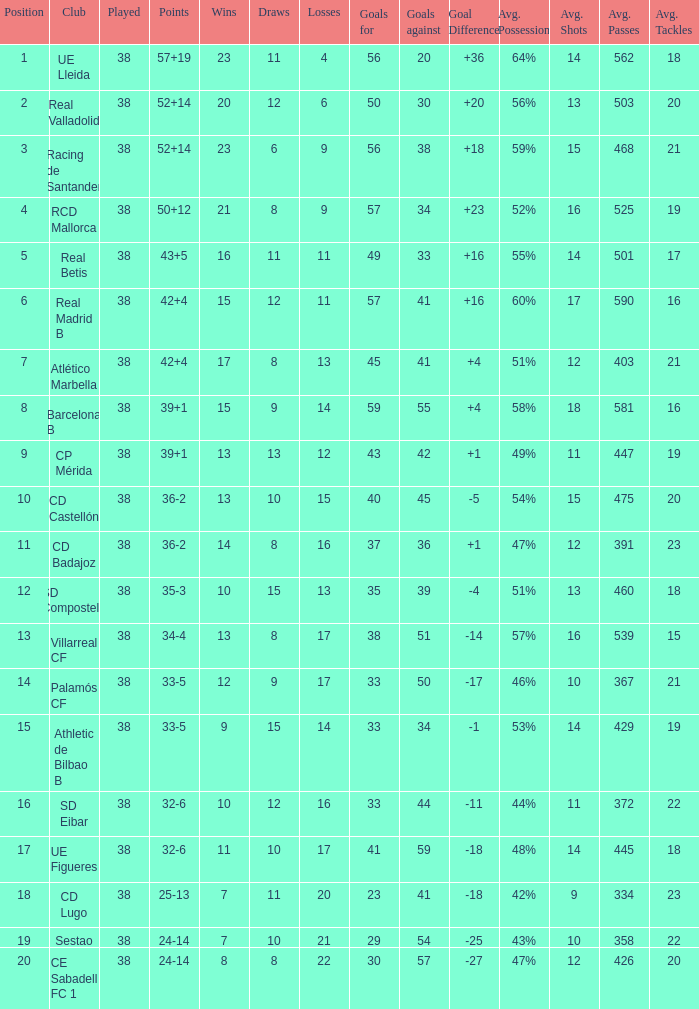Parse the table in full. {'header': ['Position', 'Club', 'Played', 'Points', 'Wins', 'Draws', 'Losses', 'Goals for', 'Goals against', 'Goal Difference', 'Avg. Possession', 'Avg. Shots', 'Avg. Passes', 'Avg. Tackles'], 'rows': [['1', 'UE Lleida', '38', '57+19', '23', '11', '4', '56', '20', '+36', '64%', '14', '562', '18'], ['2', 'Real Valladolid', '38', '52+14', '20', '12', '6', '50', '30', '+20', '56%', '13', '503', '20'], ['3', 'Racing de Santander', '38', '52+14', '23', '6', '9', '56', '38', '+18', '59%', '15', '468', '21'], ['4', 'RCD Mallorca', '38', '50+12', '21', '8', '9', '57', '34', '+23', '52%', '16', '525', '19'], ['5', 'Real Betis', '38', '43+5', '16', '11', '11', '49', '33', '+16', '55%', '14', '501', '17'], ['6', 'Real Madrid B', '38', '42+4', '15', '12', '11', '57', '41', '+16', '60%', '17', '590', '16'], ['7', 'Atlético Marbella', '38', '42+4', '17', '8', '13', '45', '41', '+4', '51%', '12', '403', '21'], ['8', 'Barcelona B', '38', '39+1', '15', '9', '14', '59', '55', '+4', '58%', '18', '581', '16'], ['9', 'CP Mérida', '38', '39+1', '13', '13', '12', '43', '42', '+1', '49%', '11', '447', '19'], ['10', 'CD Castellón', '38', '36-2', '13', '10', '15', '40', '45', '-5', '54%', '15', '475', '20'], ['11', 'CD Badajoz', '38', '36-2', '14', '8', '16', '37', '36', '+1', '47%', '12', '391', '23'], ['12', 'SD Compostela', '38', '35-3', '10', '15', '13', '35', '39', '-4', '51%', '13', '460', '18'], ['13', 'Villarreal CF', '38', '34-4', '13', '8', '17', '38', '51', '-14', '57%', '16', '539', '15'], ['14', 'Palamós CF', '38', '33-5', '12', '9', '17', '33', '50', '-17', '46%', '10', '367', '21'], ['15', 'Athletic de Bilbao B', '38', '33-5', '9', '15', '14', '33', '34', '-1', '53%', '14', '429', '19'], ['16', 'SD Eibar', '38', '32-6', '10', '12', '16', '33', '44', '-11', '44%', '11', '372', '22'], ['17', 'UE Figueres', '38', '32-6', '11', '10', '17', '41', '59', '-18', '48%', '14', '445', '18'], ['18', 'CD Lugo', '38', '25-13', '7', '11', '20', '23', '41', '-18', '42%', '9', '334', '23'], ['19', 'Sestao', '38', '24-14', '7', '10', '21', '29', '54', '-25', '43%', '10', '358', '22'], ['20', 'CE Sabadell FC 1', '38', '24-14', '8', '8', '22', '30', '57', '-27', '47%', '12', '426', '20']]} What is the highest number of wins with a goal difference less than 4 at the Villarreal CF and more than 38 played? None. 